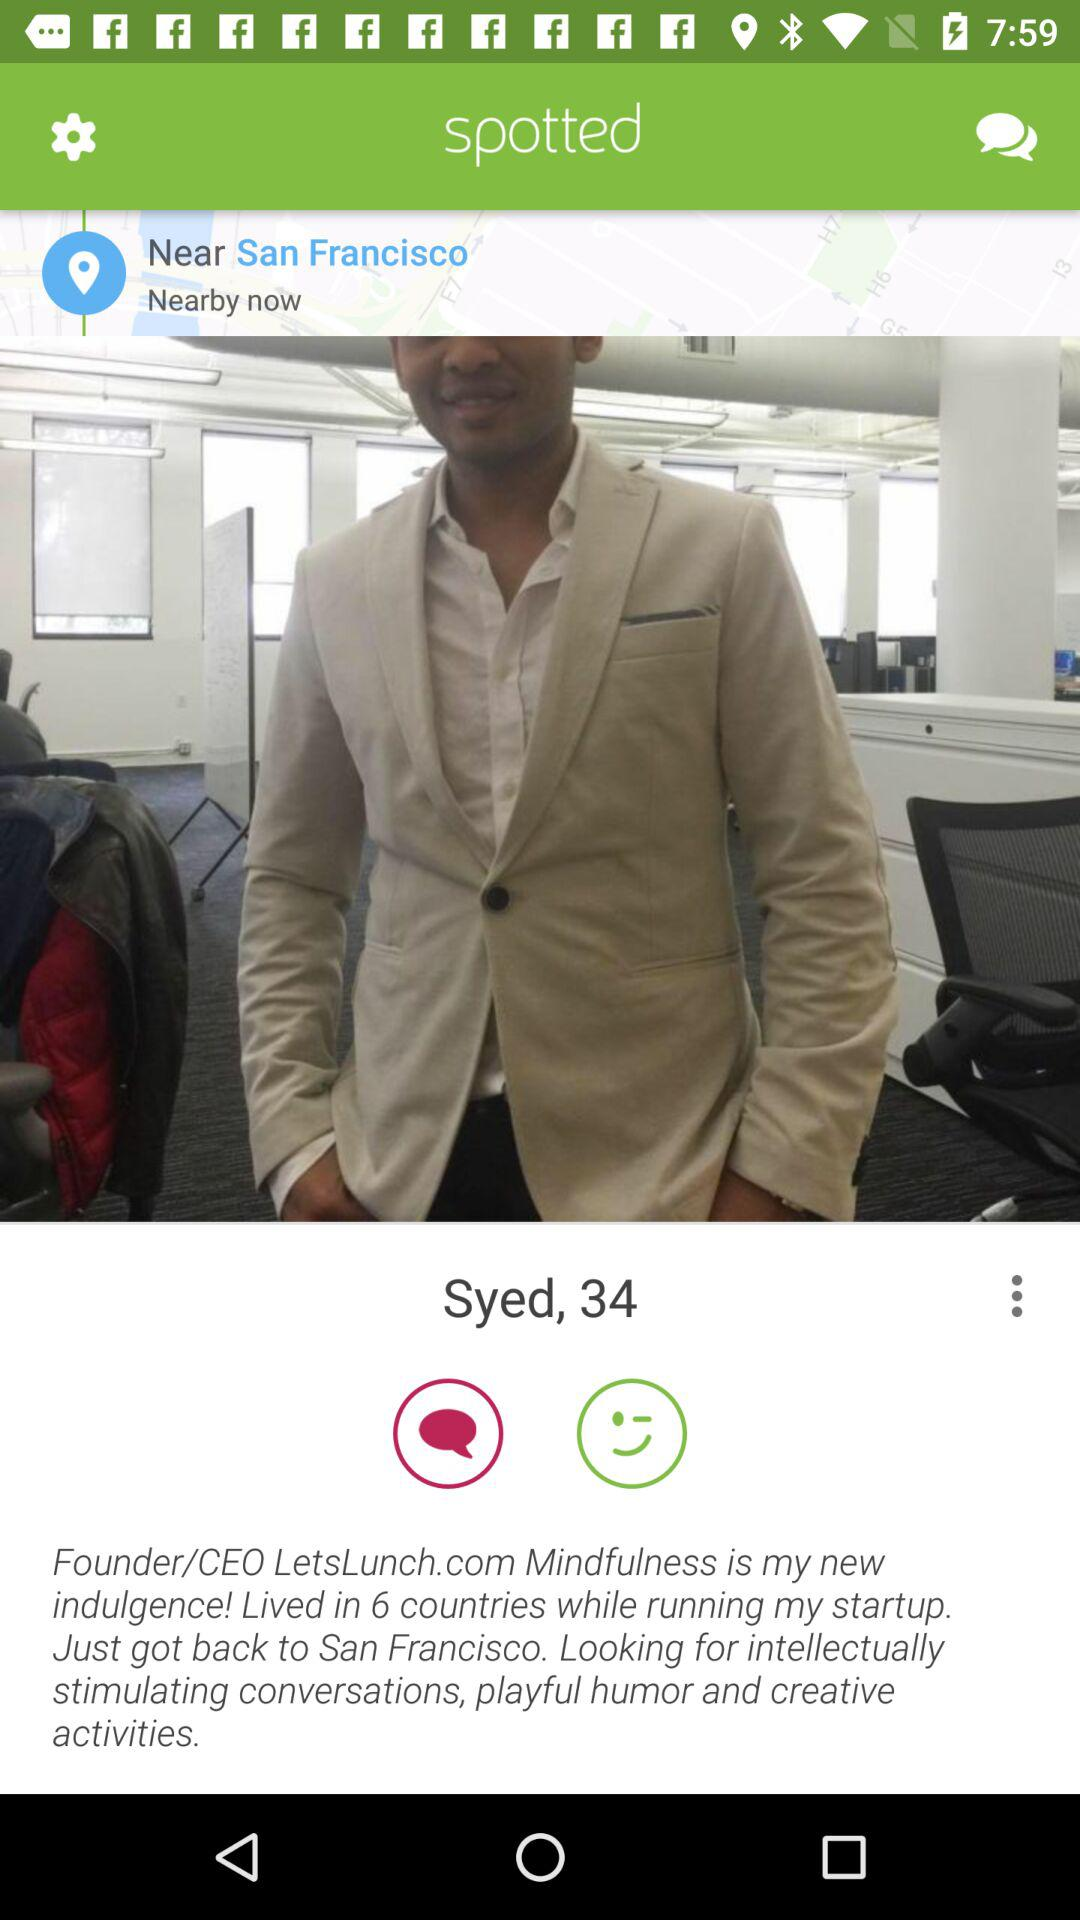Who is the founder of LetsLunch.com? The founder of LetsLunch.com is Syed. 